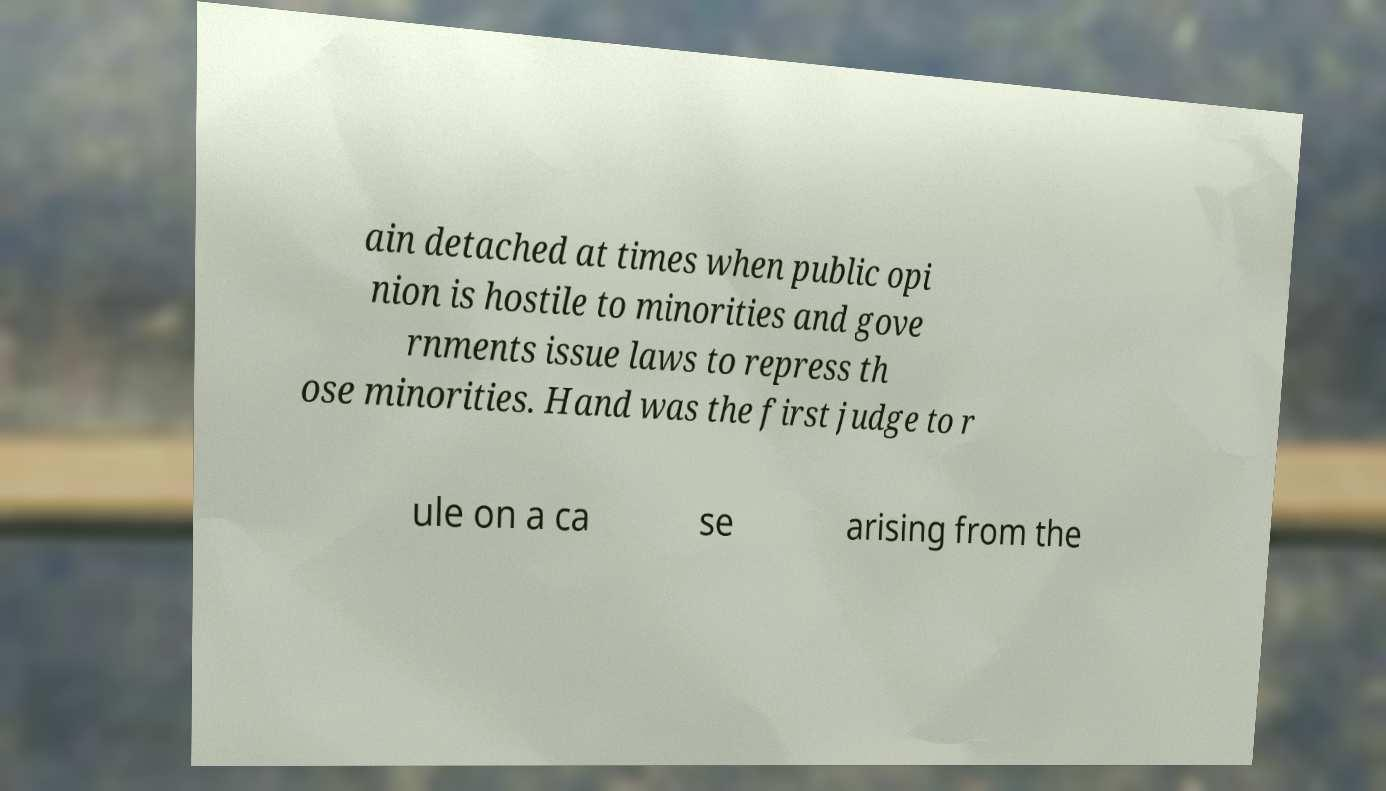I need the written content from this picture converted into text. Can you do that? ain detached at times when public opi nion is hostile to minorities and gove rnments issue laws to repress th ose minorities. Hand was the first judge to r ule on a ca se arising from the 